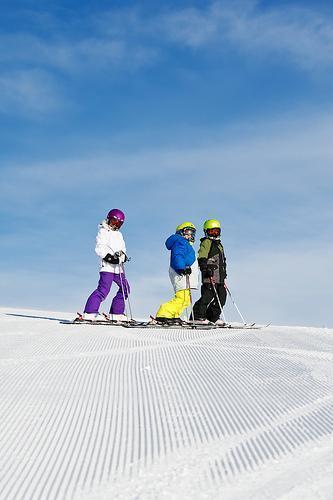How many skiers?
Give a very brief answer. 3. 